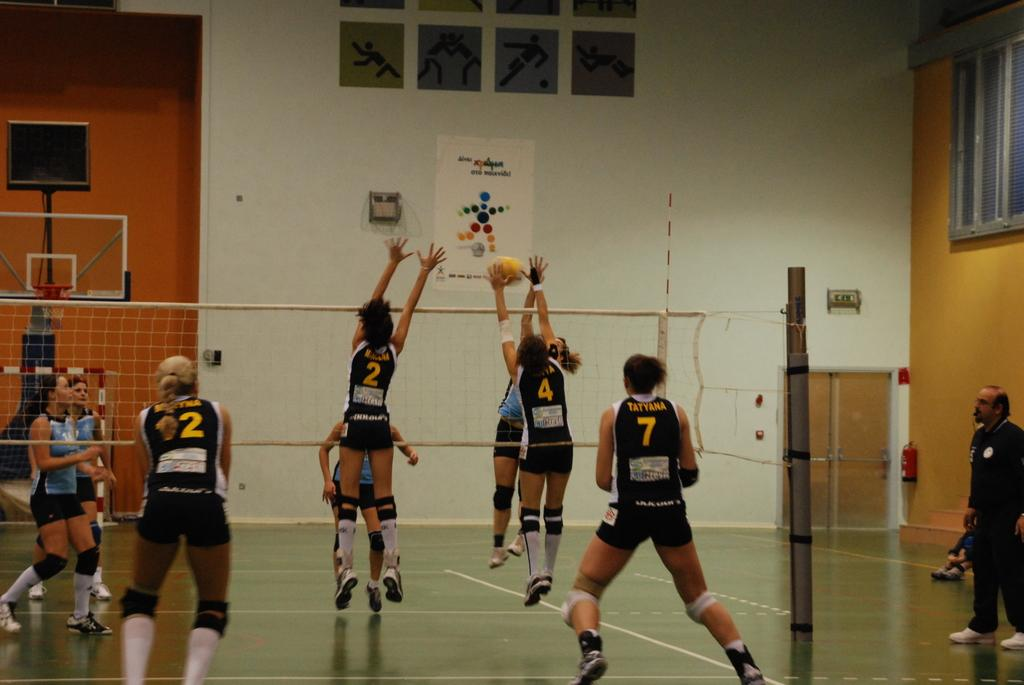What type of sports court is visible in the image? There is a volleyball court in the image. What activity are the players engaged in? The players are playing volleyball in the image. What can be seen in the background of the image? There are frames, a wall, windows, a door, and a basketball net in the background of the image. How many lamps are present in the image? There are no lamps visible in the image. What type of stove is used by the players during the game? There is no stove present in the image, as it is a volleyball court and players do not use stoves during the game. 